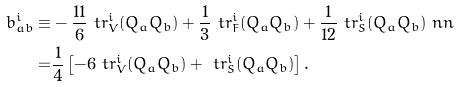Convert formula to latex. <formula><loc_0><loc_0><loc_500><loc_500>b _ { a b } ^ { i } \equiv & - \frac { 1 1 } { 6 } \ t r ^ { i } _ { V } ( Q _ { a } Q _ { b } ) + \frac { 1 } { 3 } \ t r ^ { i } _ { F } ( Q _ { a } Q _ { b } ) + \frac { 1 } { 1 2 } \ t r ^ { i } _ { S } ( Q _ { a } Q _ { b } ) \ n n \\ = & \frac { 1 } { 4 } \left [ - 6 \ t r ^ { i } _ { V } ( Q _ { a } Q _ { b } ) + \ t r ^ { i } _ { S } ( Q _ { a } Q _ { b } ) \right ] .</formula> 